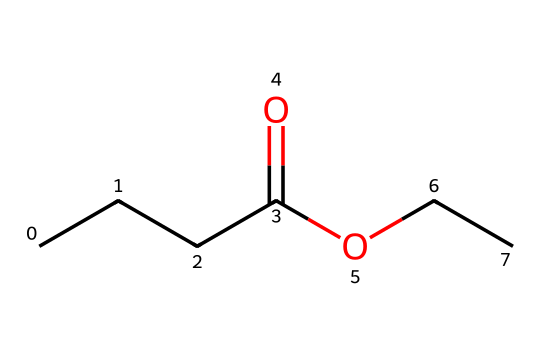How many carbon atoms are in ethyl butyrate? By examining the SMILES representation (CCCC(=O)OCC), we count four carbon atoms in the butyrate part (CCCC) and two in the ethyl group (CC), totaling six carbon atoms.
Answer: six What type of functional group is present in ethyl butyrate? The SMILES shows the presence of a carbonyl group (C=O) and an ester linkage (C-O-C), indicating that ethyl butyrate is an ester.
Answer: ester What is the total number of oxygen atoms in ethyl butyrate? From the SMILES string, we can see one carbonyl oxygen (=O) and one ether oxygen (O), which totals two oxygen atoms in the molecule.
Answer: two How does the presence of the ethyl group affect the volatility of ethyl butyrate? The ethyl group typically increases the volatility due to lower molecular weight and contributes to a more pronounced fruity aroma, which is characteristic of esters.
Answer: increases What characteristic aroma does ethyl butyrate impart to sports drinks? Ethyl butyrate is known for its fruity scent, often described as having notes reminiscent of pineapple or apple, making it appealing in flavor profiles for sports drinks.
Answer: fruity How many hydrogen atoms are in the molecular composition of ethyl butyrate? To find the number of hydrogen atoms, we consider the structure: the four carbon atoms in the chain contribute eight hydrogen atoms, and the two in the ethyl group contribute five, totaling thirteen hydrogen atoms.
Answer: thirteen 